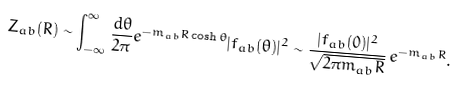Convert formula to latex. <formula><loc_0><loc_0><loc_500><loc_500>Z _ { a b } ( R ) \sim \int _ { - \infty } ^ { \infty } \frac { d \theta } { 2 \pi } { e } ^ { - m _ { a b } R \cosh \theta } | f _ { a b } ( \theta ) | ^ { 2 } \sim \frac { | f _ { a b } ( 0 ) | ^ { 2 } } { \sqrt { 2 \pi m _ { a b } R } } \, { e } ^ { - m _ { a b } R } .</formula> 